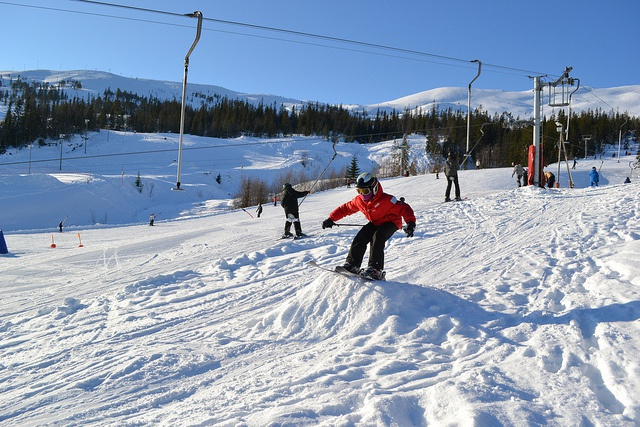Describe the objects in this image and their specific colors. I can see people in lightblue, black, maroon, and lightgray tones, people in lightblue, black, gray, darkgray, and lightgray tones, people in lightblue, black, darkgray, and gray tones, people in lightblue, black, gray, lightgray, and darkgray tones, and skis in lightblue, gray, darkgray, black, and lightgray tones in this image. 